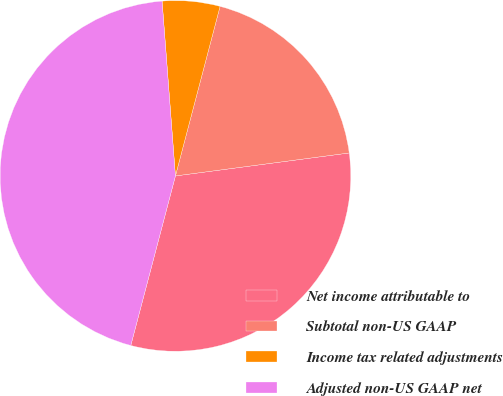Convert chart. <chart><loc_0><loc_0><loc_500><loc_500><pie_chart><fcel>Net income attributable to<fcel>Subtotal non-US GAAP<fcel>Income tax related adjustments<fcel>Adjusted non-US GAAP net<nl><fcel>31.19%<fcel>18.81%<fcel>5.31%<fcel>44.69%<nl></chart> 